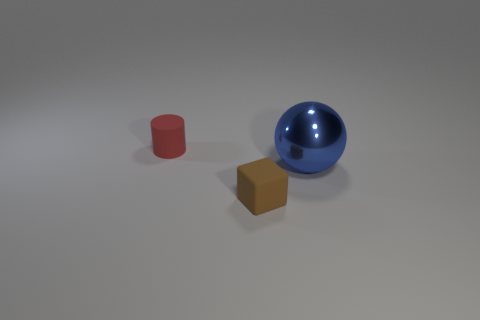There is another rubber thing that is the same size as the red matte thing; what shape is it?
Your answer should be compact. Cube. Are there any large metallic spheres that are left of the matte thing on the right side of the rubber object behind the blue sphere?
Provide a short and direct response. No. Is there a red cube that has the same size as the brown rubber object?
Provide a succinct answer. No. There is a matte object behind the blue object; what size is it?
Offer a very short reply. Small. What color is the object that is right of the matte object that is to the right of the small thing behind the tiny brown thing?
Provide a succinct answer. Blue. There is a matte thing that is behind the small thing that is right of the red thing; what color is it?
Keep it short and to the point. Red. Is the number of matte cylinders that are to the left of the big blue shiny thing greater than the number of small rubber objects to the left of the small cylinder?
Provide a succinct answer. Yes. Does the small object in front of the small red cylinder have the same material as the object on the right side of the brown block?
Offer a terse response. No. There is a matte block; are there any small red cylinders behind it?
Provide a succinct answer. Yes. How many purple objects are either shiny balls or small rubber cylinders?
Your answer should be very brief. 0. 